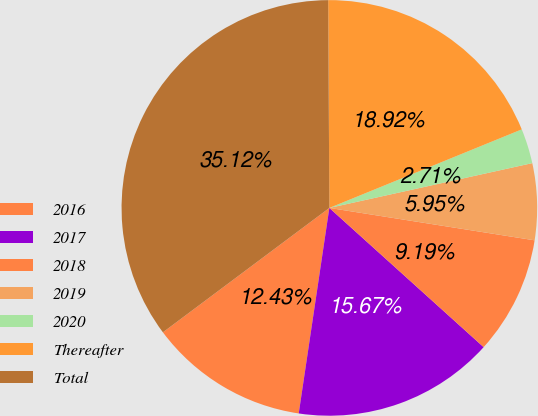<chart> <loc_0><loc_0><loc_500><loc_500><pie_chart><fcel>2016<fcel>2017<fcel>2018<fcel>2019<fcel>2020<fcel>Thereafter<fcel>Total<nl><fcel>12.43%<fcel>15.67%<fcel>9.19%<fcel>5.95%<fcel>2.71%<fcel>18.92%<fcel>35.12%<nl></chart> 